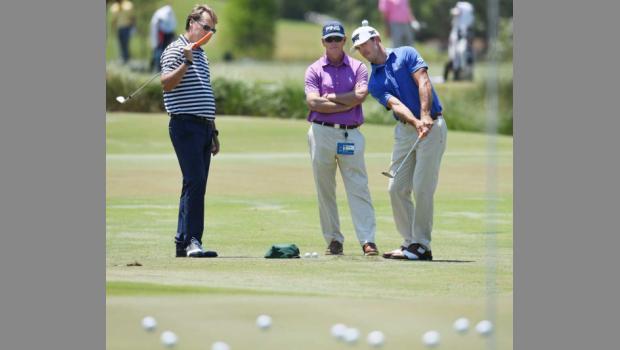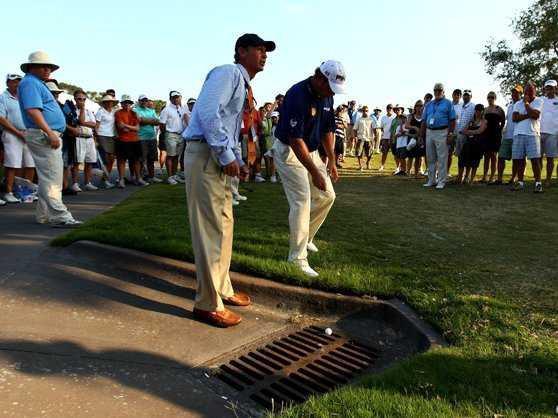The first image is the image on the left, the second image is the image on the right. Evaluate the accuracy of this statement regarding the images: "A red and white checked flag sits on the golf course in one of the images.". Is it true? Answer yes or no. No. The first image is the image on the left, the second image is the image on the right. Evaluate the accuracy of this statement regarding the images: "An image shows a group of people on a golf green with a red checkered flag on a pole.". Is it true? Answer yes or no. No. 